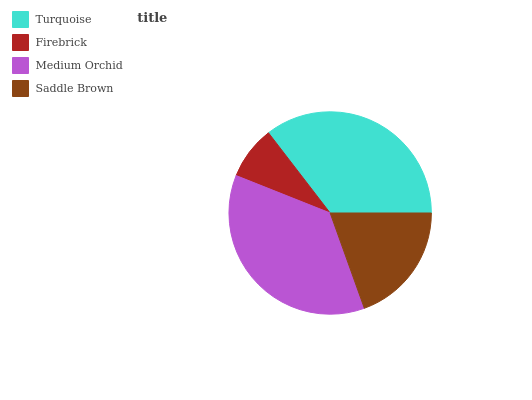Is Firebrick the minimum?
Answer yes or no. Yes. Is Medium Orchid the maximum?
Answer yes or no. Yes. Is Medium Orchid the minimum?
Answer yes or no. No. Is Firebrick the maximum?
Answer yes or no. No. Is Medium Orchid greater than Firebrick?
Answer yes or no. Yes. Is Firebrick less than Medium Orchid?
Answer yes or no. Yes. Is Firebrick greater than Medium Orchid?
Answer yes or no. No. Is Medium Orchid less than Firebrick?
Answer yes or no. No. Is Turquoise the high median?
Answer yes or no. Yes. Is Saddle Brown the low median?
Answer yes or no. Yes. Is Saddle Brown the high median?
Answer yes or no. No. Is Firebrick the low median?
Answer yes or no. No. 